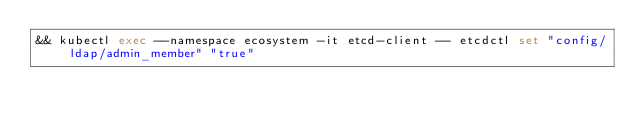Convert code to text. <code><loc_0><loc_0><loc_500><loc_500><_Bash_>&& kubectl exec --namespace ecosystem -it etcd-client -- etcdctl set "config/ldap/admin_member" "true"</code> 